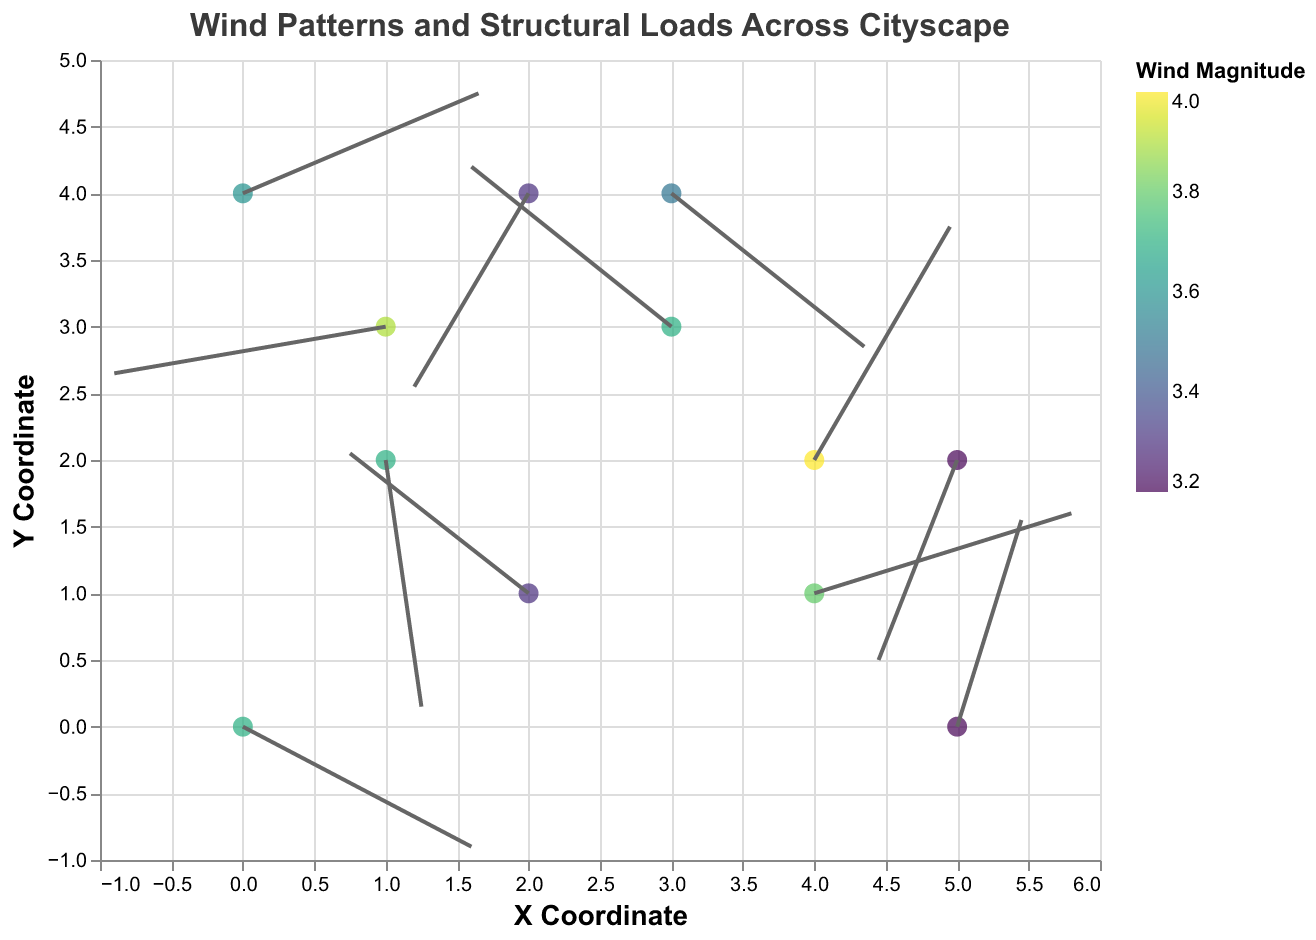What is the title of the plot? The title of the plot is displayed at the top of the figure, which is "Wind Patterns and Structural Loads Across Cityscape".
Answer: Wind Patterns and Structural Loads Across Cityscape How many data points are plotted in the figure? Each data point represents a specific location on the plot, with its own coordinates. There are 12 unique locations represented in the data.
Answer: 12 Which location experiences the highest wind magnitude? The wind magnitudes are represented by the color scale. By examining the color legend and the tooltip information, Riverside Promenade has the highest wind magnitude of 4.0.
Answer: Riverside Promenade What are the x and y coordinates for Central Park? Central Park can be located by checking the tooltip for position and coordinates in the data, which are marked with 'x: 2' and 'y: 1' in the data.
Answer: x: 2, y: 1 What is the wind direction and magnitude at the University Campus? By referring to the data and tooltip, the University Campus has a wind vector of (u: 2.7, v: -2.3), and a magnitude of 3.5.
Answer: Direction: (2.7, -2.3); Magnitude: 3.5 Which coordinates have a vector pointing mostly in the positive x direction and significant wind magnitude? Checking the data entries, Riverside Promenade (u: 1.9, v: 3.5) and Sports Stadium Complex (u: 3.6, v: 1.2) point mostly in positive x direction with wind magnitudes around 4.0 and 3.8 respectively.
Answer: Riverside Promenade and Sports Stadium Complex Comparing Downtown Financial District and University Campus, which location has a larger wind magnitude and by how much? Referring to the magnitudes in the data, Downtown Financial District has a magnitude of 3.7 and University Campus has 3.5. So, 3.7 - 3.5 = 0.2
Answer: Downtown Financial District by 0.2 What is the sum of x coordinates for the locations with negative u components? Identifying negative u components in Central Park (2), Industrial Zone (1), High-rise Residential Area (2), Shopping District (3), and Airport Zone (5), the sum is 2 + 1 + 2 + 3 + 5 = 13.
Answer: 13 Which vector has the largest combined negative component (u + v negative)? Adding the u and v components together for all vectors with both negative signs, High-rise Residential Area (-1.6, -2.9) sums to -4.5, which is the largest.
Answer: High-rise Residential Area 